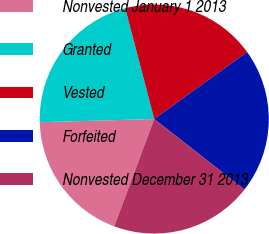Convert chart. <chart><loc_0><loc_0><loc_500><loc_500><pie_chart><fcel>Nonvested January 1 2013<fcel>Granted<fcel>Vested<fcel>Forfeited<fcel>Nonvested December 31 2013<nl><fcel>18.88%<fcel>21.37%<fcel>19.13%<fcel>20.51%<fcel>20.11%<nl></chart> 